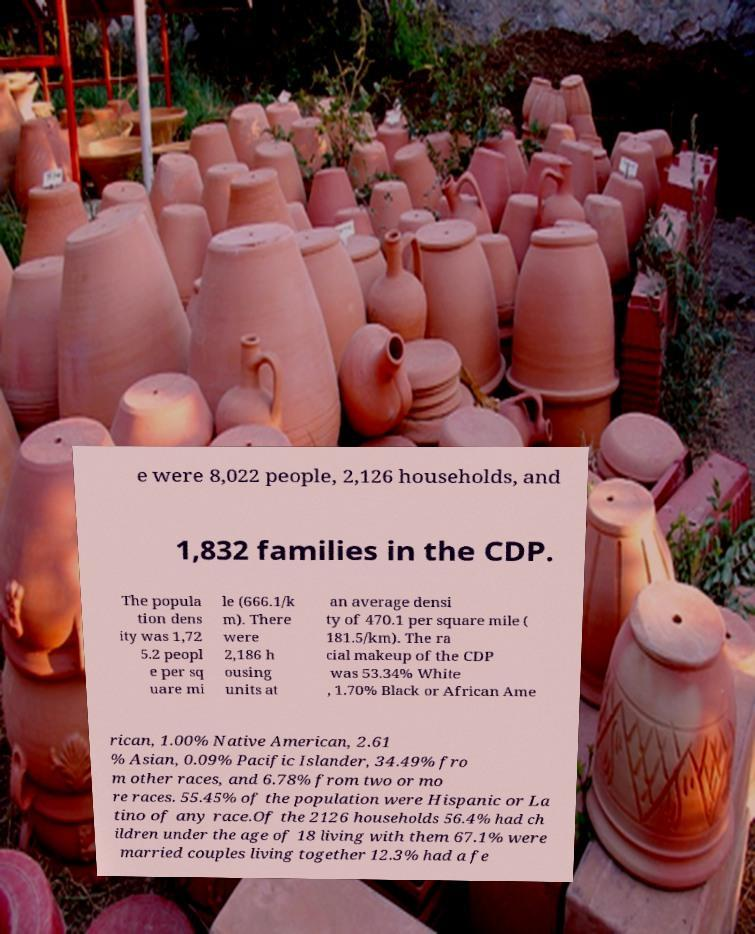There's text embedded in this image that I need extracted. Can you transcribe it verbatim? e were 8,022 people, 2,126 households, and 1,832 families in the CDP. The popula tion dens ity was 1,72 5.2 peopl e per sq uare mi le (666.1/k m). There were 2,186 h ousing units at an average densi ty of 470.1 per square mile ( 181.5/km). The ra cial makeup of the CDP was 53.34% White , 1.70% Black or African Ame rican, 1.00% Native American, 2.61 % Asian, 0.09% Pacific Islander, 34.49% fro m other races, and 6.78% from two or mo re races. 55.45% of the population were Hispanic or La tino of any race.Of the 2126 households 56.4% had ch ildren under the age of 18 living with them 67.1% were married couples living together 12.3% had a fe 